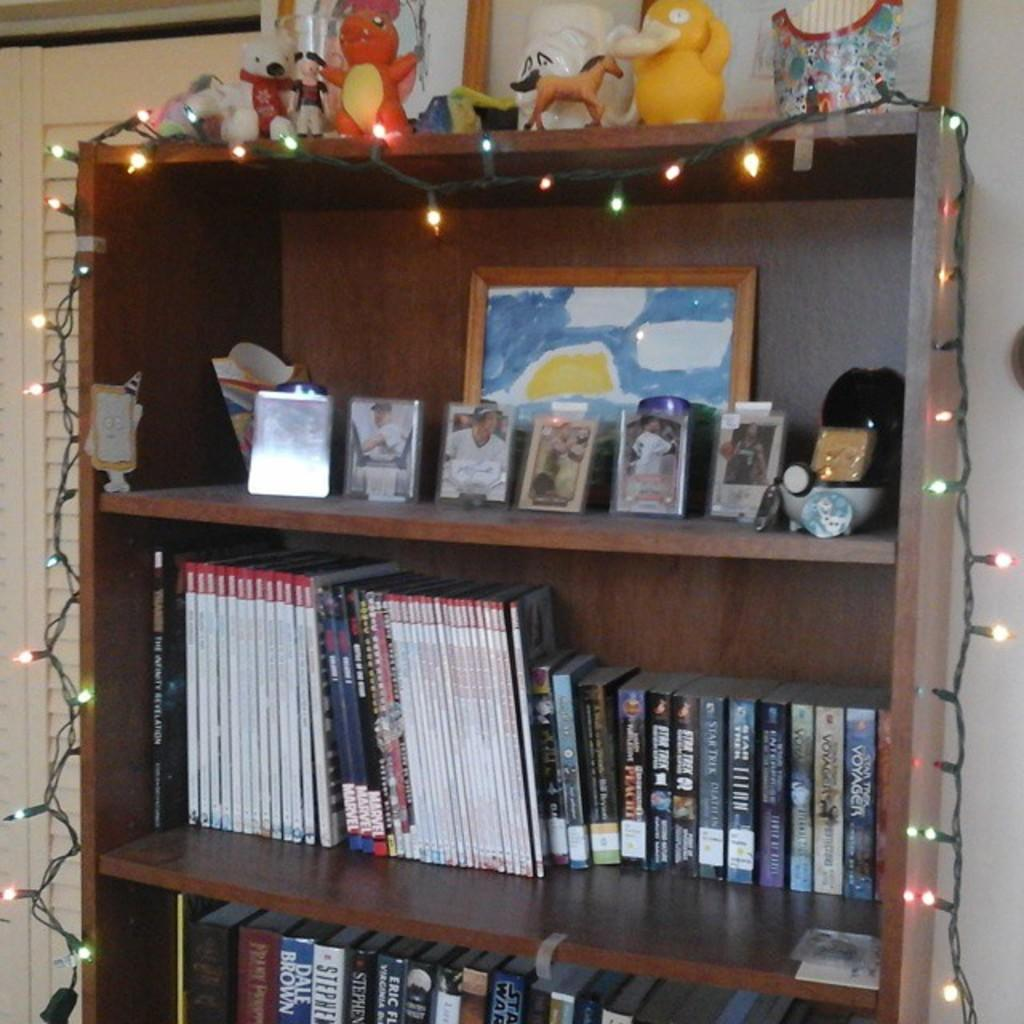What type of furniture is present in the image? There is a cupboard in the image. What items can be found inside the cupboard? The cupboard contains books, awards, and pictures. How are the items arranged inside the cupboard? The books, awards, and pictures are arranged on shelves. What additional objects are placed on top of the cupboard? There are dolls and lights on top of the cupboard. How many rabbits are present in the image? There are no rabbits present in the image. What type of company is associated with the items in the cupboard? There is no company mentioned or associated with the items in the cupboard. 